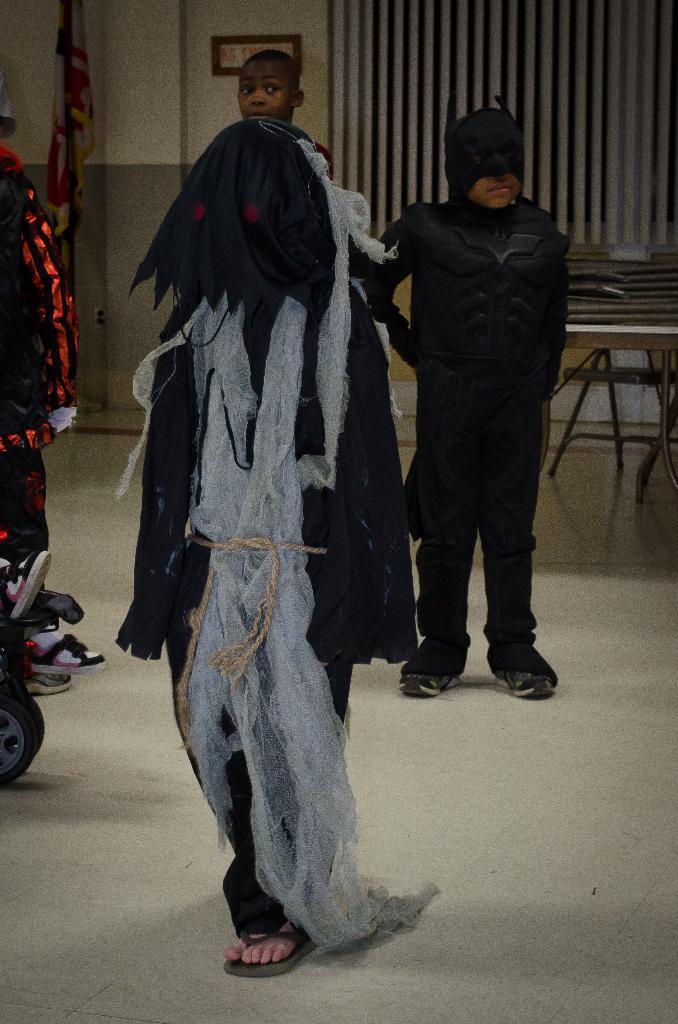Could you give a brief overview of what you see in this image? In the image few people are standing. Behind them there is a table. At the top of the image there is a wall and there is a pole and flag. 